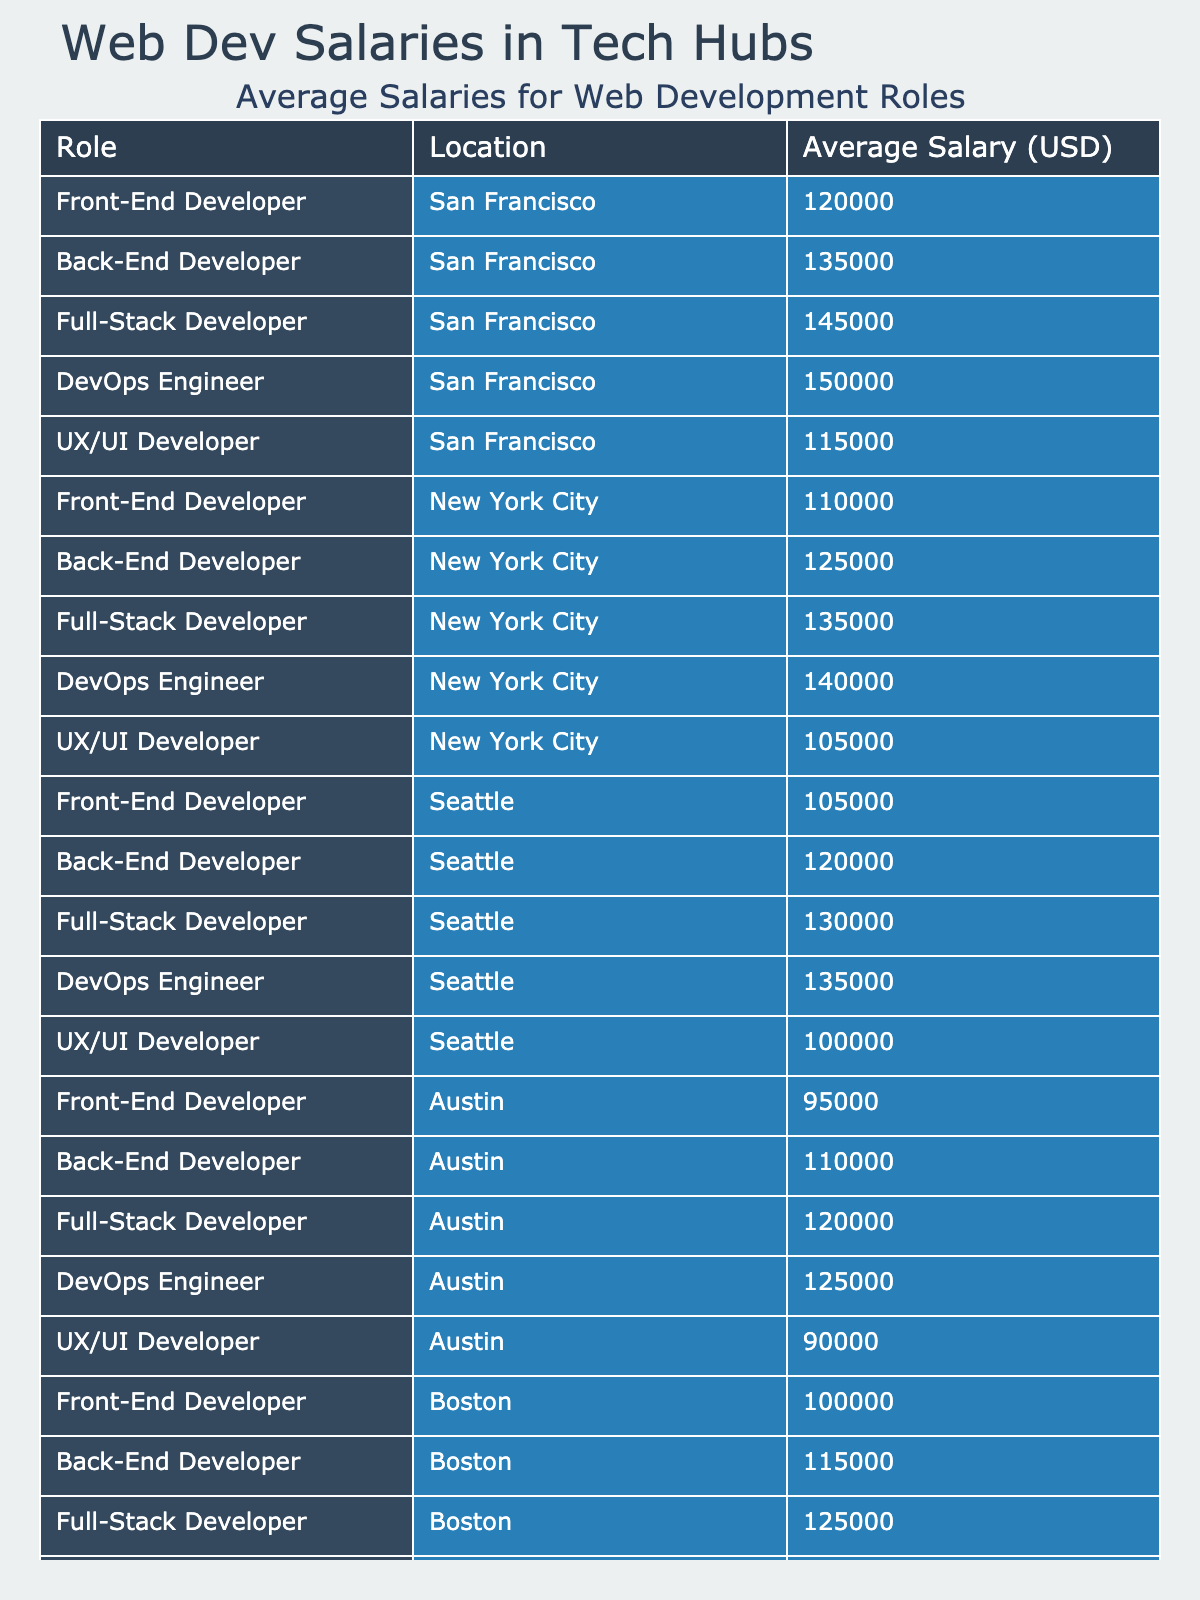What is the average salary for a Full-Stack Developer in New York City? The table indicates that the average salary for a Full-Stack Developer in New York City is listed as 135000.
Answer: 135000 Which location offers the highest average salary for a DevOps Engineer? By comparing the average salaries of DevOps Engineers across the locations, San Francisco has the highest average salary of 150000.
Answer: San Francisco What is the average salary difference between Front-End Developers in San Francisco and Austin? The average salary for a Front-End Developer in San Francisco is 120000, while in Austin it is 95000. The difference is 120000 - 95000 = 25000.
Answer: 25000 Is the average salary for a UX/UI Developer in Seattle greater than that in Boston? The average salary for a UX/UI Developer in Seattle is 100000, while in Boston it is 95000. Since 100000 is greater than 95000, the statement is true.
Answer: Yes What is the average salary of Back-End Developers across all listed locations? The average salaries for Back-End Developers are: San Francisco (135000), New York City (125000), Seattle (120000), Austin (110000), and Boston (115000). Adding these gives 135000 + 125000 + 120000 + 110000 + 115000 = 605000. Dividing by 5, the average is 605000 / 5 = 121000.
Answer: 121000 Which role has the lowest average salary in Austin? In Austin, the average salaries are: Front-End Developer (95000), Back-End Developer (110000), Full-Stack Developer (120000), DevOps Engineer (125000), and UX/UI Developer (90000). The lowest of these is 90000 for the UX/UI Developer.
Answer: UX/UI Developer How much more does a Full-Stack Developer in San Francisco earn compared to one in Seattle? The average salary for a Full-Stack Developer in San Francisco is 145000 and in Seattle it is 130000. The difference is 145000 - 130000 = 15000.
Answer: 15000 Which city has the highest average salary for UX/UI Developers? The average salaries for UX/UI Developers are: San Francisco (115000), New York City (105000), Seattle (100000), Austin (90000), and Boston (95000). San Francisco has the highest at 115000.
Answer: San Francisco Are Back-End Developers in Seattle paid more than Full-Stack Developers in Austin? The average salary for Back-End Developers in Seattle is 120000, while Full-Stack Developers in Austin earn 120000 as well. Since they are equal, the statement is false.
Answer: No What is the overall highest paying web development role across all locations? By comparing all roles' average salaries, DevOps Engineer in San Francisco has the highest at 150000.
Answer: DevOps Engineer in San Francisco 